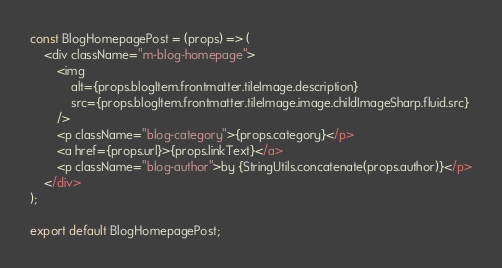Convert code to text. <code><loc_0><loc_0><loc_500><loc_500><_JavaScript_>
const BlogHomepagePost = (props) => (
    <div className="m-blog-homepage">
        <img
            alt={props.blogItem.frontmatter.tileImage.description}
            src={props.blogItem.frontmatter.tileImage.image.childImageSharp.fluid.src}
        />
        <p className="blog-category">{props.category}</p>
        <a href={props.url}>{props.linkText}</a>
        <p className="blog-author">by {StringUtils.concatenate(props.author)}</p>
    </div>
);

export default BlogHomepagePost;
</code> 